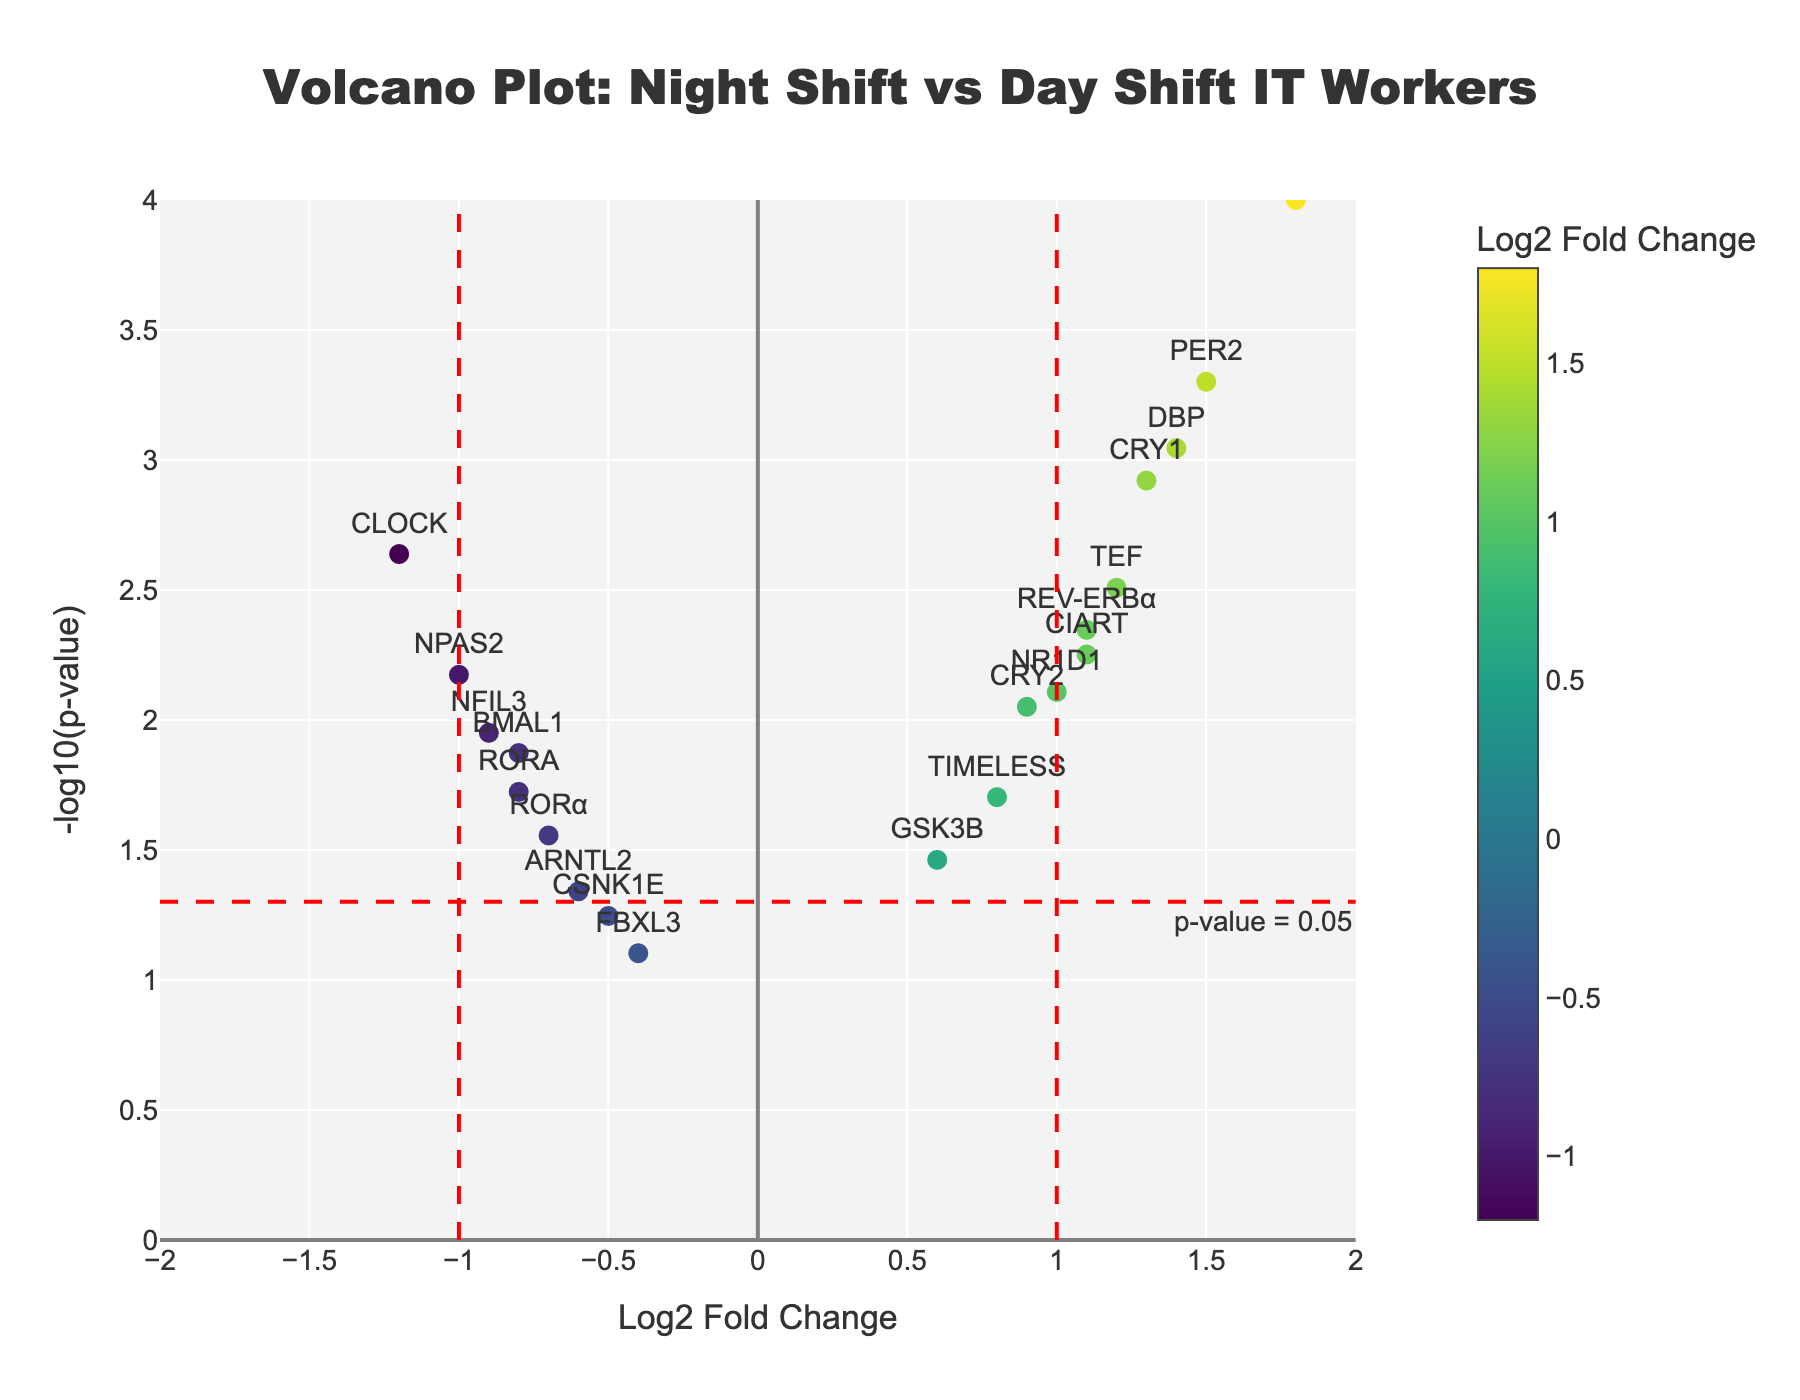How many genes have a log2 fold change greater than 1? We need to count the number of data points where the x-axis value (log2 fold change) is greater than 1. By inspecting the plot, we see the genes PER1, PER2, CRY1, DBP, and TEF.
Answer: 5 Which gene has the highest -log10(p-value)? We need to look at the y-axis values and identify which gene reaches the highest point. PER1 has the highest -log10(p-value).
Answer: PER1 Are there more genes with negative log2 fold changes or positive log2 fold changes? By inspecting the distribution of points left and right of zero on the x-axis, we count the points on each side. There are more genes with positive log2 fold changes.
Answer: Positive How many genes are above the p-value threshold line (p-value = 0.05)? We locate the threshold line on the y-axis and count the points above this line (-log10(0.05) ≈ 1.3). Genes above this threshold are CLOCK, PER1, PER2, CRY1, CRY2, NPAS2, DBP, TEF, REV-ERBα, TIMELESS, NR1D1, CIART, and NFIL3.
Answer: 13 Which gene has the most significant p-value among those with a negative log2 fold change? Among the genes with negative log2 fold change, we compare their p-values. CLOCK has the most significant p-value.
Answer: CLOCK What is the log2 fold change and p-value of the gene BMAL1? By referring to the hover information on the plot for BMAL1, we get the log2 fold change and p-value.
Answer: Log2 Fold Change: -0.8, p-value: 0.0134 Which gene falls closest to the intersection of the thresholds for log2 fold change (±1) and p-value (0.05)? We locate the intersection point of the threshold lines and find the gene that is visually closest. CRY1 is closest to the intersection point.
Answer: CRY1 What's the total number of genes plotted in the figure? We need to count the total number of data points (genes) in the plot. There are 20 genes listed.
Answer: 20 Which gene with a positive log2 fold change also has a p-value less than 0.001? We look at the data points with positive log2 fold change and check their y-axis values to find those above -log10(0.001) ≈ 3. GENES with these criteria are PER1 and PER2.
Answer: PER1 & PER2 What is the range of the -log10(p-value) axis in the plot? We need to look at the y-axis to identify the minimum and maximum values presented. The plot ranges from approximately 0 to 4.
Answer: 0 to 4 